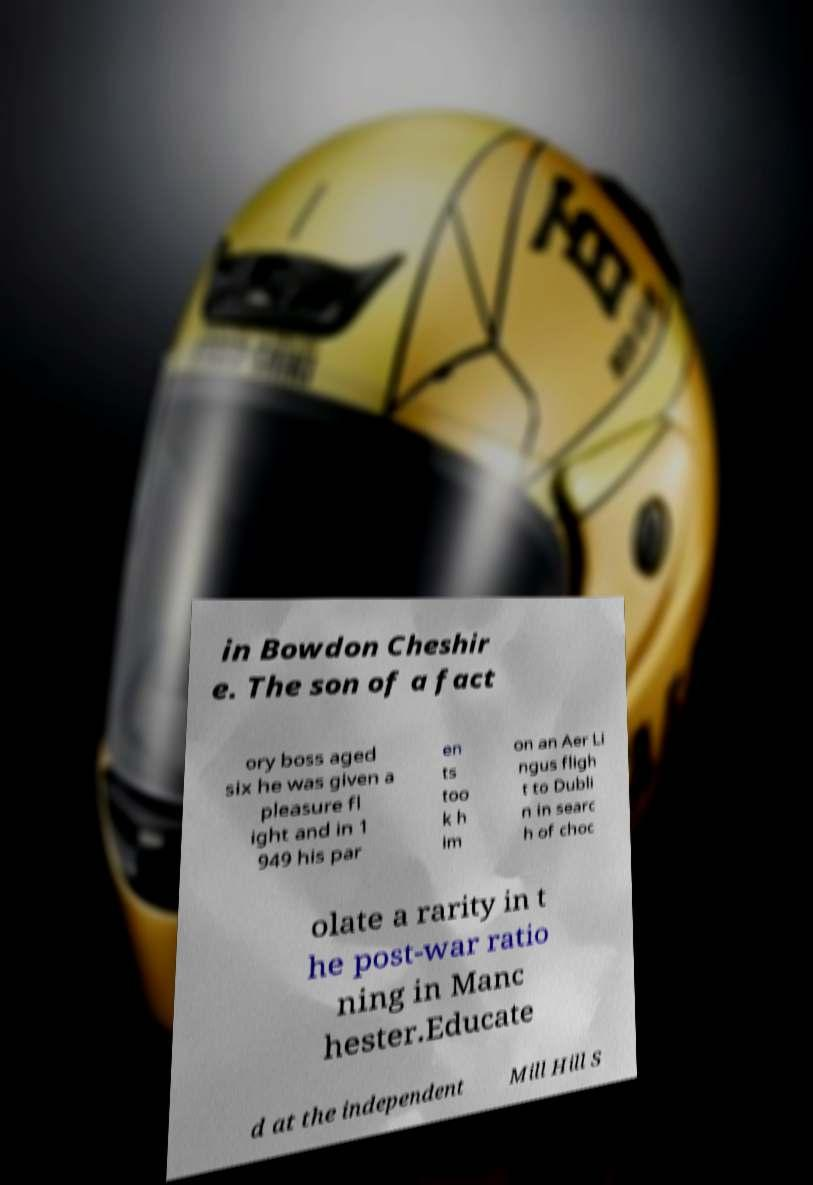For documentation purposes, I need the text within this image transcribed. Could you provide that? in Bowdon Cheshir e. The son of a fact ory boss aged six he was given a pleasure fl ight and in 1 949 his par en ts too k h im on an Aer Li ngus fligh t to Dubli n in searc h of choc olate a rarity in t he post-war ratio ning in Manc hester.Educate d at the independent Mill Hill S 